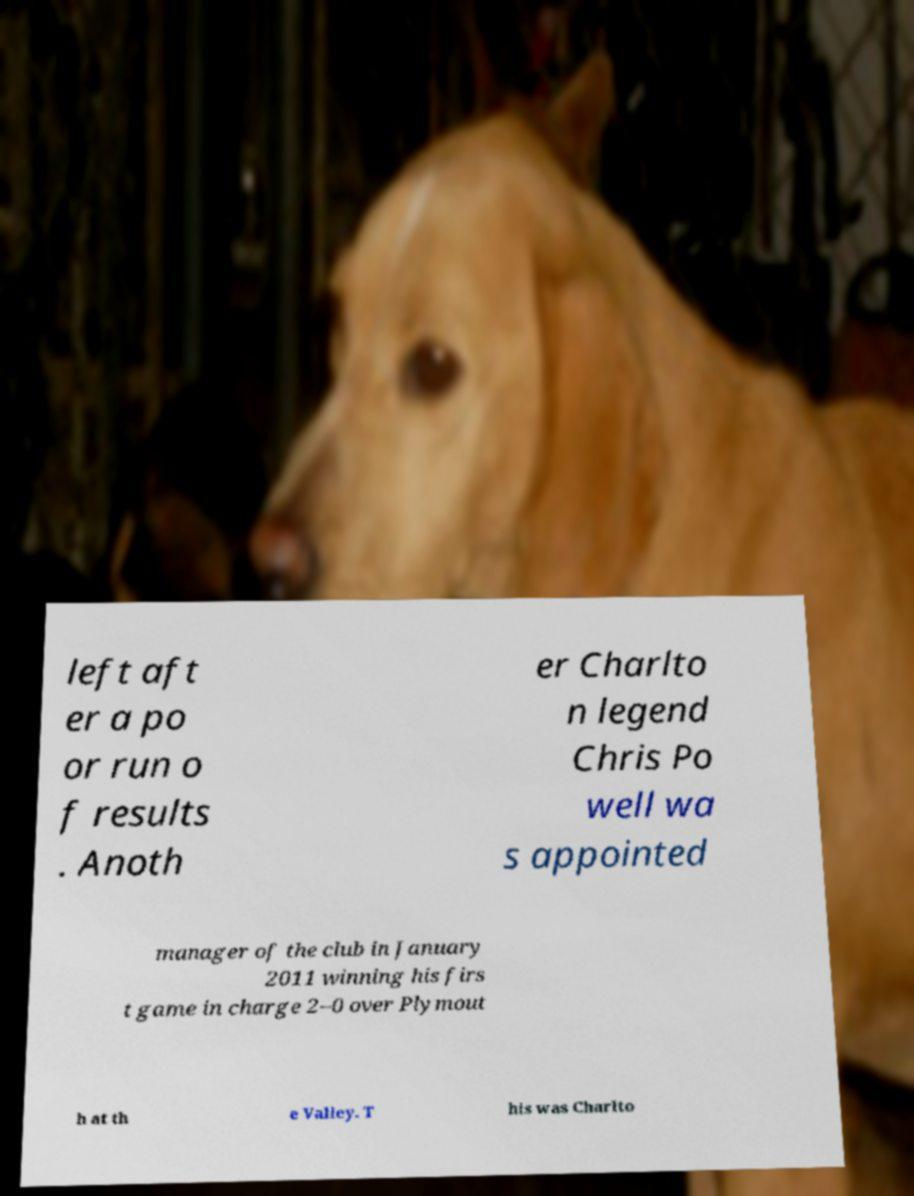Please read and relay the text visible in this image. What does it say? left aft er a po or run o f results . Anoth er Charlto n legend Chris Po well wa s appointed manager of the club in January 2011 winning his firs t game in charge 2–0 over Plymout h at th e Valley. T his was Charlto 